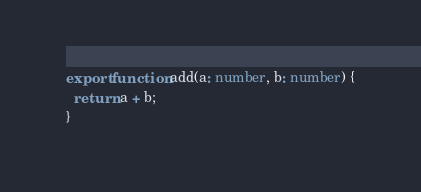<code> <loc_0><loc_0><loc_500><loc_500><_TypeScript_>export function add(a: number, b: number) {
  return a + b;
}</code> 